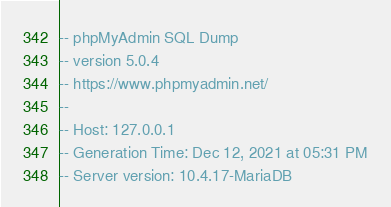<code> <loc_0><loc_0><loc_500><loc_500><_SQL_>-- phpMyAdmin SQL Dump
-- version 5.0.4
-- https://www.phpmyadmin.net/
--
-- Host: 127.0.0.1
-- Generation Time: Dec 12, 2021 at 05:31 PM
-- Server version: 10.4.17-MariaDB</code> 